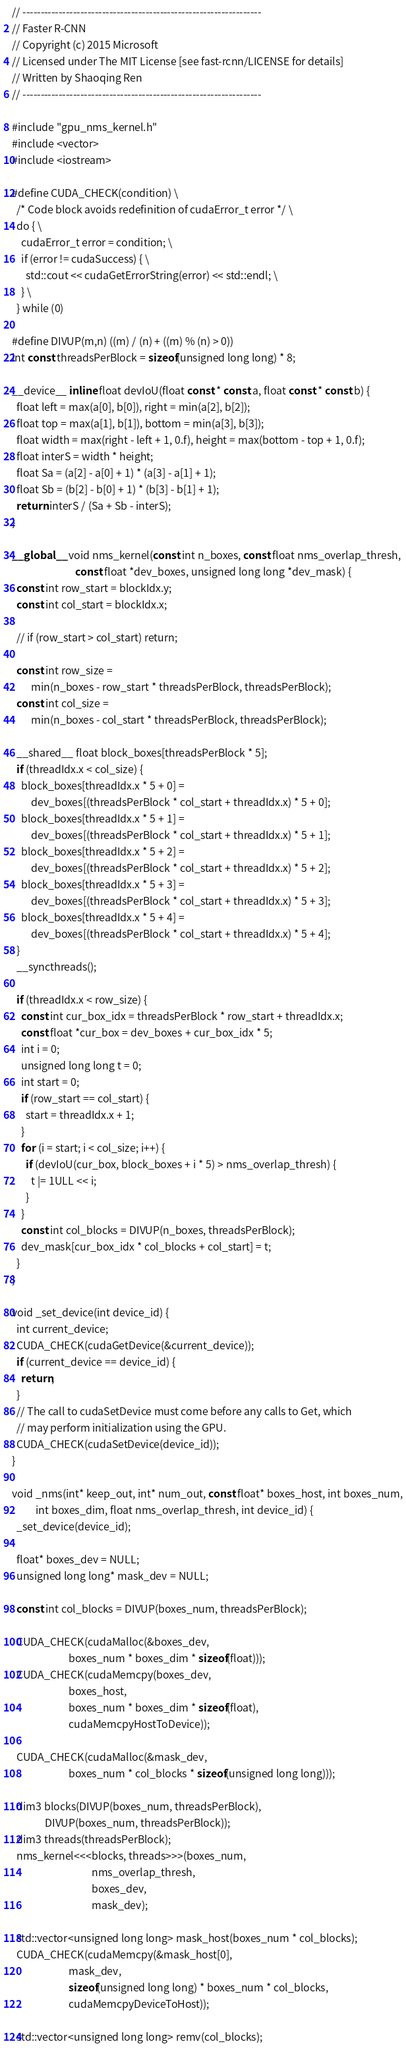<code> <loc_0><loc_0><loc_500><loc_500><_Cuda_>// ------------------------------------------------------------------
// Faster R-CNN
// Copyright (c) 2015 Microsoft
// Licensed under The MIT License [see fast-rcnn/LICENSE for details]
// Written by Shaoqing Ren
// ------------------------------------------------------------------

#include "gpu_nms_kernel.h"
#include <vector>
#include <iostream>

#define CUDA_CHECK(condition) \
  /* Code block avoids redefinition of cudaError_t error */ \
  do { \
    cudaError_t error = condition; \
    if (error != cudaSuccess) { \
      std::cout << cudaGetErrorString(error) << std::endl; \
    } \
  } while (0)

#define DIVUP(m,n) ((m) / (n) + ((m) % (n) > 0))
int const threadsPerBlock = sizeof(unsigned long long) * 8;

__device__ inline float devIoU(float const * const a, float const * const b) {
  float left = max(a[0], b[0]), right = min(a[2], b[2]);
  float top = max(a[1], b[1]), bottom = min(a[3], b[3]);
  float width = max(right - left + 1, 0.f), height = max(bottom - top + 1, 0.f);
  float interS = width * height;
  float Sa = (a[2] - a[0] + 1) * (a[3] - a[1] + 1);
  float Sb = (b[2] - b[0] + 1) * (b[3] - b[1] + 1);
  return interS / (Sa + Sb - interS);
}

__global__ void nms_kernel(const int n_boxes, const float nms_overlap_thresh,
                           const float *dev_boxes, unsigned long long *dev_mask) {
  const int row_start = blockIdx.y;
  const int col_start = blockIdx.x;

  // if (row_start > col_start) return;

  const int row_size =
        min(n_boxes - row_start * threadsPerBlock, threadsPerBlock);
  const int col_size =
        min(n_boxes - col_start * threadsPerBlock, threadsPerBlock);

  __shared__ float block_boxes[threadsPerBlock * 5];
  if (threadIdx.x < col_size) {
    block_boxes[threadIdx.x * 5 + 0] =
        dev_boxes[(threadsPerBlock * col_start + threadIdx.x) * 5 + 0];
    block_boxes[threadIdx.x * 5 + 1] =
        dev_boxes[(threadsPerBlock * col_start + threadIdx.x) * 5 + 1];
    block_boxes[threadIdx.x * 5 + 2] =
        dev_boxes[(threadsPerBlock * col_start + threadIdx.x) * 5 + 2];
    block_boxes[threadIdx.x * 5 + 3] =
        dev_boxes[(threadsPerBlock * col_start + threadIdx.x) * 5 + 3];
    block_boxes[threadIdx.x * 5 + 4] =
        dev_boxes[(threadsPerBlock * col_start + threadIdx.x) * 5 + 4];
  }
  __syncthreads();

  if (threadIdx.x < row_size) {
    const int cur_box_idx = threadsPerBlock * row_start + threadIdx.x;
    const float *cur_box = dev_boxes + cur_box_idx * 5;
    int i = 0;
    unsigned long long t = 0;
    int start = 0;
    if (row_start == col_start) {
      start = threadIdx.x + 1;
    }
    for (i = start; i < col_size; i++) {
      if (devIoU(cur_box, block_boxes + i * 5) > nms_overlap_thresh) {
        t |= 1ULL << i;
      }
    }
    const int col_blocks = DIVUP(n_boxes, threadsPerBlock);
    dev_mask[cur_box_idx * col_blocks + col_start] = t;
  }
}

void _set_device(int device_id) {
  int current_device;
  CUDA_CHECK(cudaGetDevice(&current_device));
  if (current_device == device_id) {
    return;
  }
  // The call to cudaSetDevice must come before any calls to Get, which
  // may perform initialization using the GPU.
  CUDA_CHECK(cudaSetDevice(device_id));
}

void _nms(int* keep_out, int* num_out, const float* boxes_host, int boxes_num,
          int boxes_dim, float nms_overlap_thresh, int device_id) {
  _set_device(device_id);

  float* boxes_dev = NULL;
  unsigned long long* mask_dev = NULL;

  const int col_blocks = DIVUP(boxes_num, threadsPerBlock);

  CUDA_CHECK(cudaMalloc(&boxes_dev,
                        boxes_num * boxes_dim * sizeof(float)));
  CUDA_CHECK(cudaMemcpy(boxes_dev,
                        boxes_host,
                        boxes_num * boxes_dim * sizeof(float),
                        cudaMemcpyHostToDevice));

  CUDA_CHECK(cudaMalloc(&mask_dev,
                        boxes_num * col_blocks * sizeof(unsigned long long)));

  dim3 blocks(DIVUP(boxes_num, threadsPerBlock),
              DIVUP(boxes_num, threadsPerBlock));
  dim3 threads(threadsPerBlock);
  nms_kernel<<<blocks, threads>>>(boxes_num,
                                  nms_overlap_thresh,
                                  boxes_dev,
                                  mask_dev);

  std::vector<unsigned long long> mask_host(boxes_num * col_blocks);
  CUDA_CHECK(cudaMemcpy(&mask_host[0],
                        mask_dev,
                        sizeof(unsigned long long) * boxes_num * col_blocks,
                        cudaMemcpyDeviceToHost));

  std::vector<unsigned long long> remv(col_blocks);</code> 